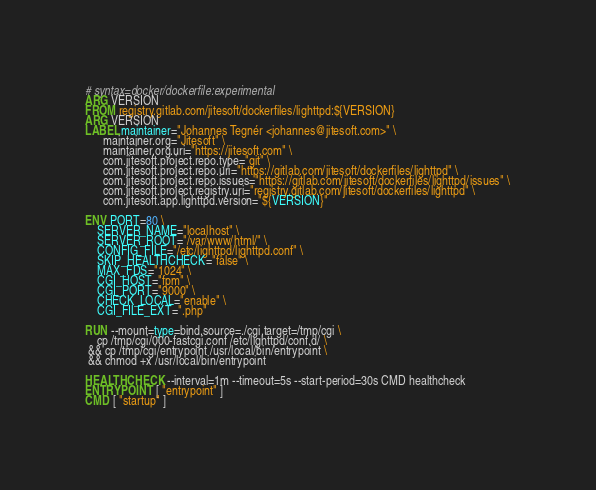<code> <loc_0><loc_0><loc_500><loc_500><_Dockerfile_># syntax=docker/dockerfile:experimental
ARG VERSION
FROM registry.gitlab.com/jitesoft/dockerfiles/lighttpd:${VERSION}
ARG VERSION
LABEL maintainer="Johannes Tegnér <johannes@jitesoft.com>" \
      maintainer.org="Jitesoft" \
      maintainer.org.uri="https://jitesoft.com" \
      com.jitesoft.project.repo.type="git" \
      com.jitesoft.project.repo.uri="https://gitlab.com/jitesoft/dockerfiles/lighttpd" \
      com.jitesoft.project.repo.issues="https://gitlab.com/jitesoft/dockerfiles/lighttpd/issues" \
      com.jitesoft.project.registry.uri="registry.gitlab.com/jitesoft/dockerfiles/lighttpd" \
      com.jitesoft.app.lighttpd.version="${VERSION}"

ENV PORT=80 \
    SERVER_NAME="localhost" \
    SERVER_ROOT="/var/www/html/" \
    CONFIG_FILE="/etc/lighttpd/lighttpd.conf" \
    SKIP_HEALTHCHECK="false" \
    MAX_FDS="1024" \
    CGI_HOST="fpm" \
    CGI_PORT="9000" \
    CHECK_LOCAL="enable" \
    CGI_FILE_EXT=".php"

RUN --mount=type=bind,source=./cgi,target=/tmp/cgi \
    cp /tmp/cgi/000-fastcgi.conf /etc/lighttpd/conf.d/ \
 && cp /tmp/cgi/entrypoint /usr/local/bin/entrypoint \
 && chmod +x /usr/local/bin/entrypoint

HEALTHCHECK --interval=1m --timeout=5s --start-period=30s CMD healthcheck
ENTRYPOINT [ "entrypoint" ]
CMD [ "startup" ]
</code> 